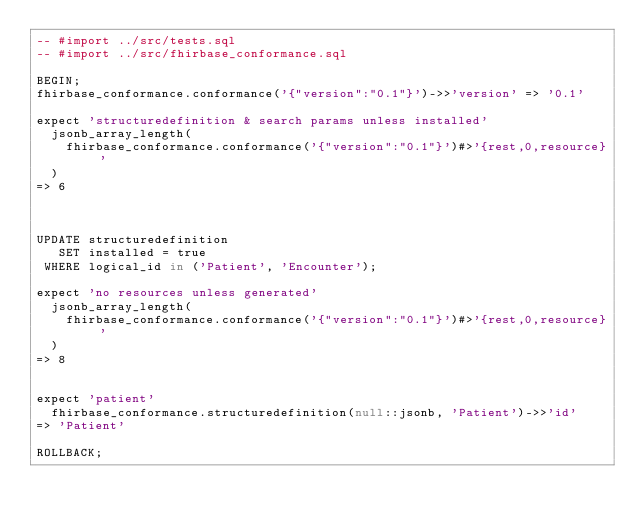<code> <loc_0><loc_0><loc_500><loc_500><_SQL_>-- #import ../src/tests.sql
-- #import ../src/fhirbase_conformance.sql

BEGIN;
fhirbase_conformance.conformance('{"version":"0.1"}')->>'version' => '0.1'

expect 'structuredefinition & search params unless installed'
  jsonb_array_length(
    fhirbase_conformance.conformance('{"version":"0.1"}')#>'{rest,0,resource}'
  )
=> 6



UPDATE structuredefinition
   SET installed = true
 WHERE logical_id in ('Patient', 'Encounter');

expect 'no resources unless generated'
  jsonb_array_length(
    fhirbase_conformance.conformance('{"version":"0.1"}')#>'{rest,0,resource}'
  )
=> 8


expect 'patient'
  fhirbase_conformance.structuredefinition(null::jsonb, 'Patient')->>'id'
=> 'Patient'

ROLLBACK;
</code> 